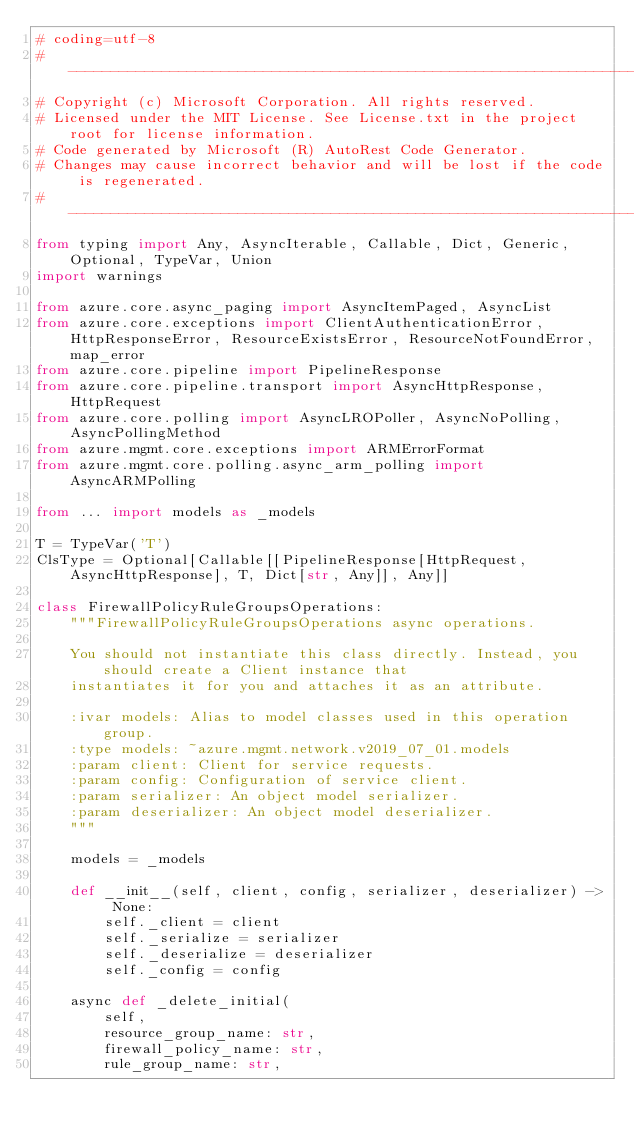<code> <loc_0><loc_0><loc_500><loc_500><_Python_># coding=utf-8
# --------------------------------------------------------------------------
# Copyright (c) Microsoft Corporation. All rights reserved.
# Licensed under the MIT License. See License.txt in the project root for license information.
# Code generated by Microsoft (R) AutoRest Code Generator.
# Changes may cause incorrect behavior and will be lost if the code is regenerated.
# --------------------------------------------------------------------------
from typing import Any, AsyncIterable, Callable, Dict, Generic, Optional, TypeVar, Union
import warnings

from azure.core.async_paging import AsyncItemPaged, AsyncList
from azure.core.exceptions import ClientAuthenticationError, HttpResponseError, ResourceExistsError, ResourceNotFoundError, map_error
from azure.core.pipeline import PipelineResponse
from azure.core.pipeline.transport import AsyncHttpResponse, HttpRequest
from azure.core.polling import AsyncLROPoller, AsyncNoPolling, AsyncPollingMethod
from azure.mgmt.core.exceptions import ARMErrorFormat
from azure.mgmt.core.polling.async_arm_polling import AsyncARMPolling

from ... import models as _models

T = TypeVar('T')
ClsType = Optional[Callable[[PipelineResponse[HttpRequest, AsyncHttpResponse], T, Dict[str, Any]], Any]]

class FirewallPolicyRuleGroupsOperations:
    """FirewallPolicyRuleGroupsOperations async operations.

    You should not instantiate this class directly. Instead, you should create a Client instance that
    instantiates it for you and attaches it as an attribute.

    :ivar models: Alias to model classes used in this operation group.
    :type models: ~azure.mgmt.network.v2019_07_01.models
    :param client: Client for service requests.
    :param config: Configuration of service client.
    :param serializer: An object model serializer.
    :param deserializer: An object model deserializer.
    """

    models = _models

    def __init__(self, client, config, serializer, deserializer) -> None:
        self._client = client
        self._serialize = serializer
        self._deserialize = deserializer
        self._config = config

    async def _delete_initial(
        self,
        resource_group_name: str,
        firewall_policy_name: str,
        rule_group_name: str,</code> 